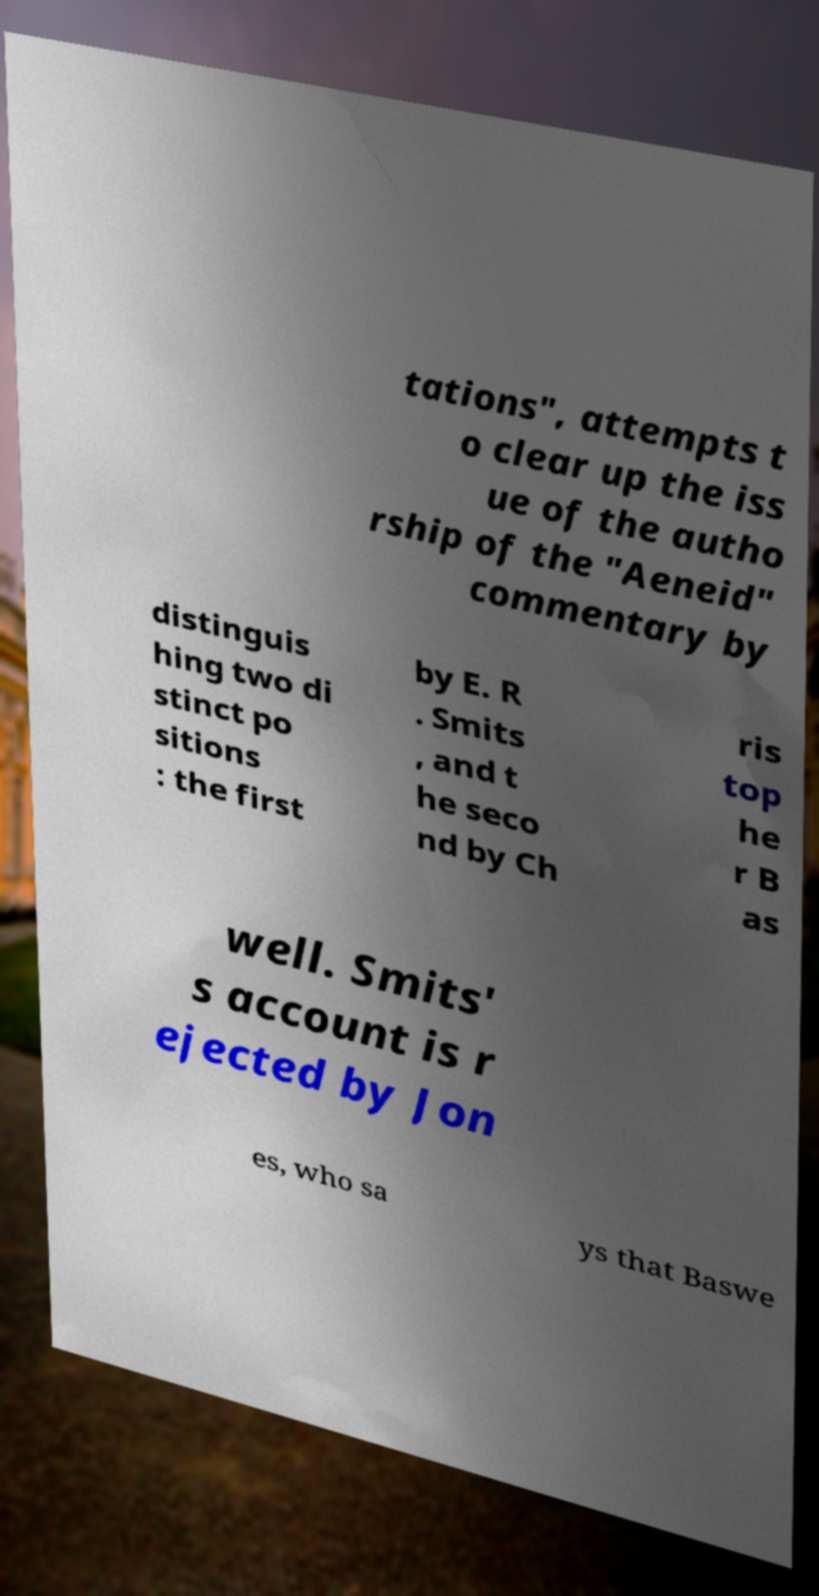Please identify and transcribe the text found in this image. tations", attempts t o clear up the iss ue of the autho rship of the "Aeneid" commentary by distinguis hing two di stinct po sitions : the first by E. R . Smits , and t he seco nd by Ch ris top he r B as well. Smits' s account is r ejected by Jon es, who sa ys that Baswe 